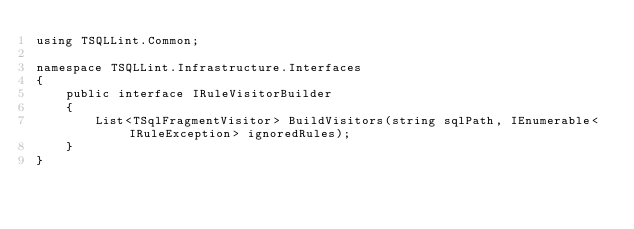Convert code to text. <code><loc_0><loc_0><loc_500><loc_500><_C#_>using TSQLLint.Common;

namespace TSQLLint.Infrastructure.Interfaces
{
    public interface IRuleVisitorBuilder
    {
        List<TSqlFragmentVisitor> BuildVisitors(string sqlPath, IEnumerable<IRuleException> ignoredRules);
    }
}
</code> 